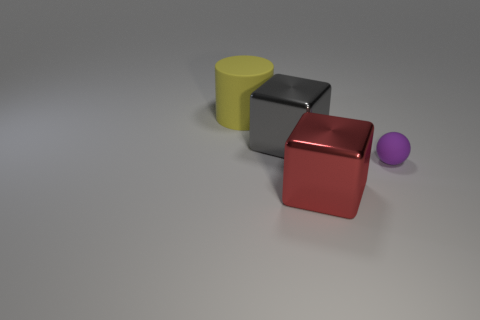What size is the sphere that is made of the same material as the yellow cylinder?
Offer a terse response. Small. Is there anything else that is the same color as the matte cylinder?
Make the answer very short. No. There is a shiny thing behind the rubber sphere; is its color the same as the rubber thing to the right of the large yellow matte thing?
Offer a very short reply. No. What color is the large cube that is in front of the small purple thing?
Provide a short and direct response. Red. There is a rubber object in front of the cylinder; is it the same size as the large yellow object?
Your answer should be very brief. No. Is the number of purple matte things less than the number of brown things?
Provide a succinct answer. No. How many rubber things are on the left side of the big red shiny block?
Ensure brevity in your answer.  1. Does the yellow thing have the same shape as the small purple object?
Your answer should be compact. No. What number of matte things are both on the left side of the purple sphere and in front of the gray metal cube?
Offer a terse response. 0. How many things are either brown matte things or large metallic blocks behind the red cube?
Provide a succinct answer. 1. 